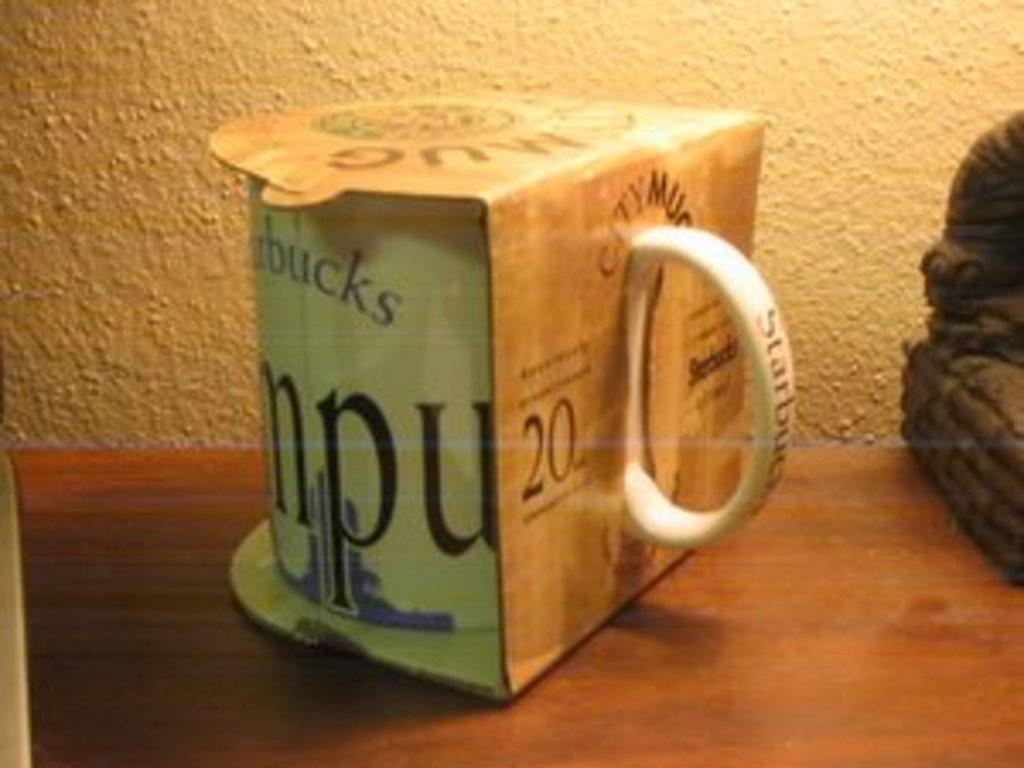<image>
Write a terse but informative summary of the picture. Unopened Starbucks cup on top of a wooden table. 